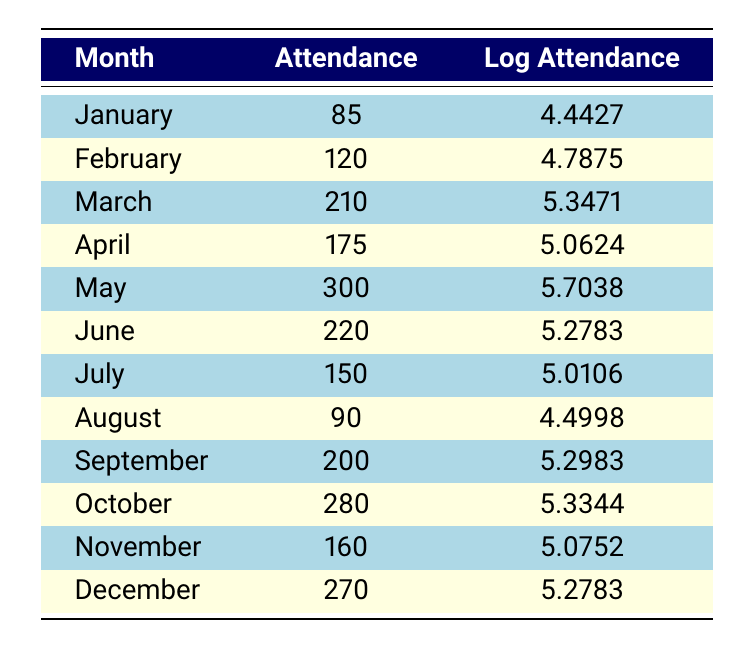What was the highest attendance recorded in any month? The attendance for each month is listed in the table. Scanning through the values, the highest attendance is in May with 300 people.
Answer: 300 Which month had the lowest attendance and what was the value? Again, referring to the attendance values, January has the lowest attendance with 85 people.
Answer: 85 What is the attendance difference between May and March? May has an attendance of 300, and March has 210. To find the difference, subtract March's attendance from May's: 300 - 210 = 90.
Answer: 90 Did any month have the same logarithmic attendance value? Looking through the logarithmic values, no two months have the same value; each entry is unique across all months.
Answer: No What is the average attendance for the second quarter (April to June)? First, sum the attendances of the second quarter: April (175) + May (300) + June (220) = 695. Then, divide by the number of months (3): 695/3 = 231.67.
Answer: 231.67 Which month shows the greatest increase in attendance from the previous month? To find the greatest increase, calculate the differences between each consecutive month: February (120 - 85 = 35), March (210 - 120 = 90), April (175 - 210 = -35), and so forth. The highest increase occurs from February to March, with an increase of 90.
Answer: 90 Was the attendance in July higher than in August? The attendance in July is 150, while in August, it is 90. Comparing these values, July's attendance is indeed higher.
Answer: Yes What is the total attendance for the last six months of the year? Adding the attendance values from July to December gives: 150 + 90 + 200 + 280 + 160 + 270 = 1150.
Answer: 1150 What was the logarithmic attendance in February compared to October? February's logarithmic attendance is 4.7875, while October's is 5.3344. Comparing these, October has a higher logarithmic value.
Answer: No 